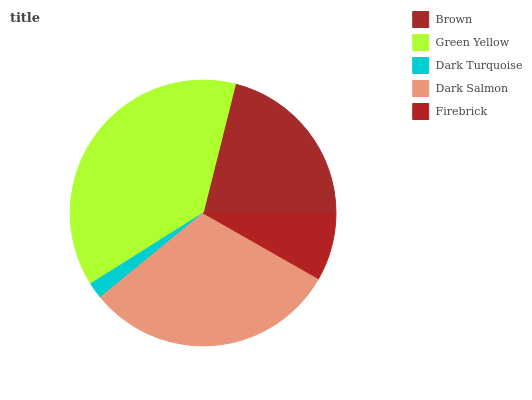Is Dark Turquoise the minimum?
Answer yes or no. Yes. Is Green Yellow the maximum?
Answer yes or no. Yes. Is Green Yellow the minimum?
Answer yes or no. No. Is Dark Turquoise the maximum?
Answer yes or no. No. Is Green Yellow greater than Dark Turquoise?
Answer yes or no. Yes. Is Dark Turquoise less than Green Yellow?
Answer yes or no. Yes. Is Dark Turquoise greater than Green Yellow?
Answer yes or no. No. Is Green Yellow less than Dark Turquoise?
Answer yes or no. No. Is Brown the high median?
Answer yes or no. Yes. Is Brown the low median?
Answer yes or no. Yes. Is Dark Turquoise the high median?
Answer yes or no. No. Is Dark Salmon the low median?
Answer yes or no. No. 